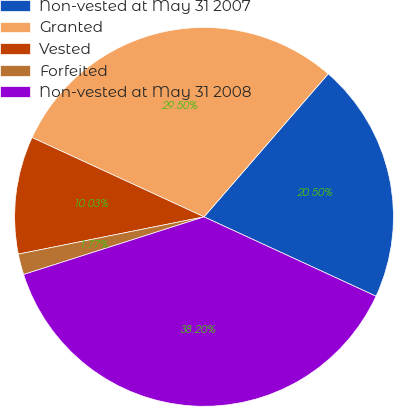Convert chart to OTSL. <chart><loc_0><loc_0><loc_500><loc_500><pie_chart><fcel>Non-vested at May 31 2007<fcel>Granted<fcel>Vested<fcel>Forfeited<fcel>Non-vested at May 31 2008<nl><fcel>20.5%<fcel>29.5%<fcel>10.03%<fcel>1.77%<fcel>38.2%<nl></chart> 